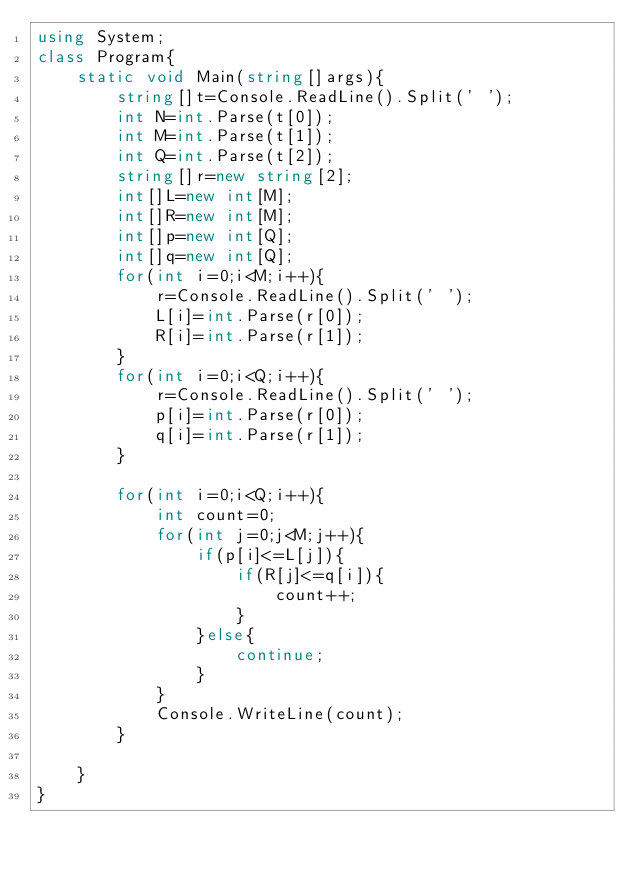Convert code to text. <code><loc_0><loc_0><loc_500><loc_500><_C#_>using System;
class Program{
    static void Main(string[]args){
        string[]t=Console.ReadLine().Split(' ');
        int N=int.Parse(t[0]);
        int M=int.Parse(t[1]);
        int Q=int.Parse(t[2]);
        string[]r=new string[2];
        int[]L=new int[M];
        int[]R=new int[M];
        int[]p=new int[Q];
        int[]q=new int[Q];
        for(int i=0;i<M;i++){
            r=Console.ReadLine().Split(' ');
            L[i]=int.Parse(r[0]);
            R[i]=int.Parse(r[1]);
        }
        for(int i=0;i<Q;i++){
            r=Console.ReadLine().Split(' ');
            p[i]=int.Parse(r[0]);
            q[i]=int.Parse(r[1]);
        }

        for(int i=0;i<Q;i++){
            int count=0;
            for(int j=0;j<M;j++){
                if(p[i]<=L[j]){
                    if(R[j]<=q[i]){
                        count++;
                    }  
                }else{
                    continue;
                }
            }
            Console.WriteLine(count);
        }
        
    }
}</code> 